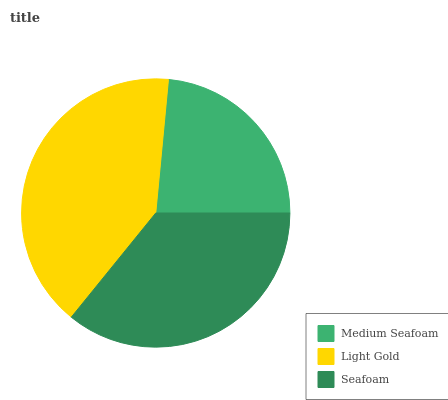Is Medium Seafoam the minimum?
Answer yes or no. Yes. Is Light Gold the maximum?
Answer yes or no. Yes. Is Seafoam the minimum?
Answer yes or no. No. Is Seafoam the maximum?
Answer yes or no. No. Is Light Gold greater than Seafoam?
Answer yes or no. Yes. Is Seafoam less than Light Gold?
Answer yes or no. Yes. Is Seafoam greater than Light Gold?
Answer yes or no. No. Is Light Gold less than Seafoam?
Answer yes or no. No. Is Seafoam the high median?
Answer yes or no. Yes. Is Seafoam the low median?
Answer yes or no. Yes. Is Light Gold the high median?
Answer yes or no. No. Is Medium Seafoam the low median?
Answer yes or no. No. 